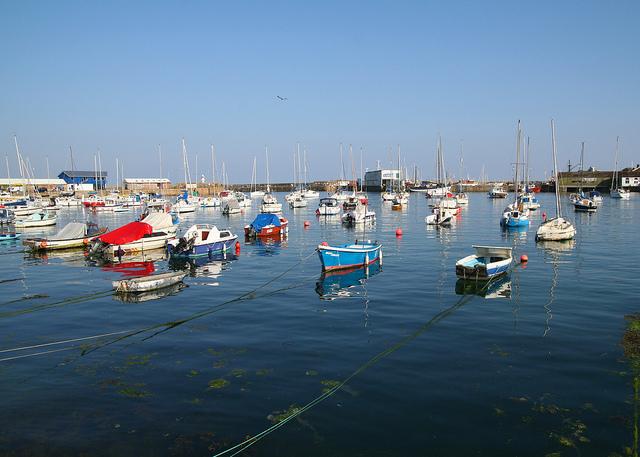How many birds are flying?
Write a very short answer. 1. Are there any clouds?
Write a very short answer. No. Are there any sailboats in this photo?
Keep it brief. Yes. 